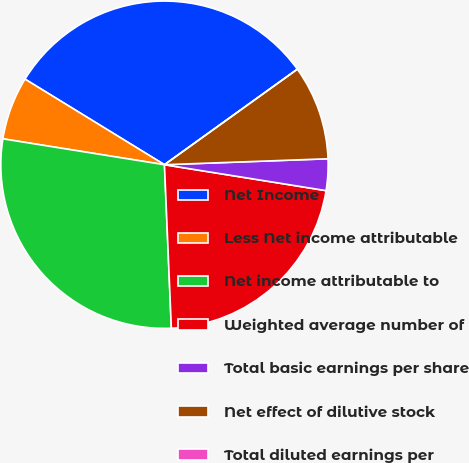<chart> <loc_0><loc_0><loc_500><loc_500><pie_chart><fcel>Net Income<fcel>Less Net income attributable<fcel>Net income attributable to<fcel>Weighted average number of<fcel>Total basic earnings per share<fcel>Net effect of dilutive stock<fcel>Total diluted earnings per<nl><fcel>31.32%<fcel>6.23%<fcel>28.2%<fcel>21.8%<fcel>3.11%<fcel>9.34%<fcel>0.0%<nl></chart> 